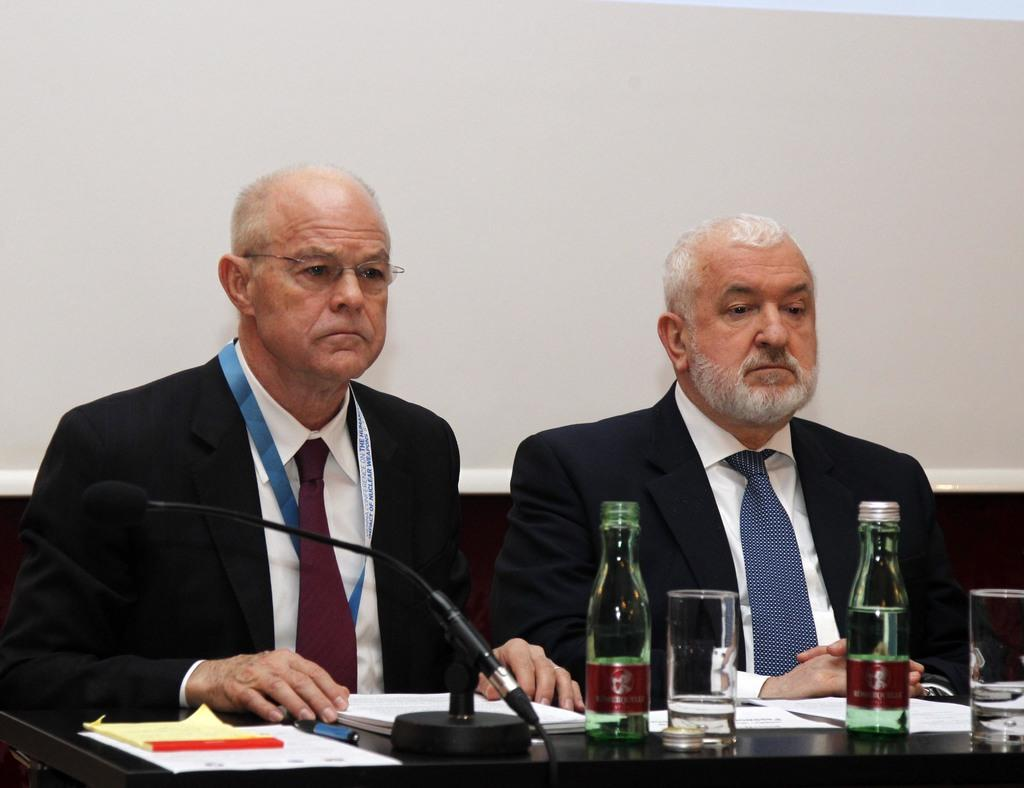What is the color of the wall in the image? The wall in the image is white. What are the two people in the image doing? A: The two people are sitting on chairs in the image. What is located in front of the chairs? There is a table in front of the chairs. What electronic device is on the table? There is a macbook on the table. What else can be seen on the table? There is a glass and bottles on the table. What type of boot is being used to inflate the bubble in the image? There is no boot or bubble present in the image. 